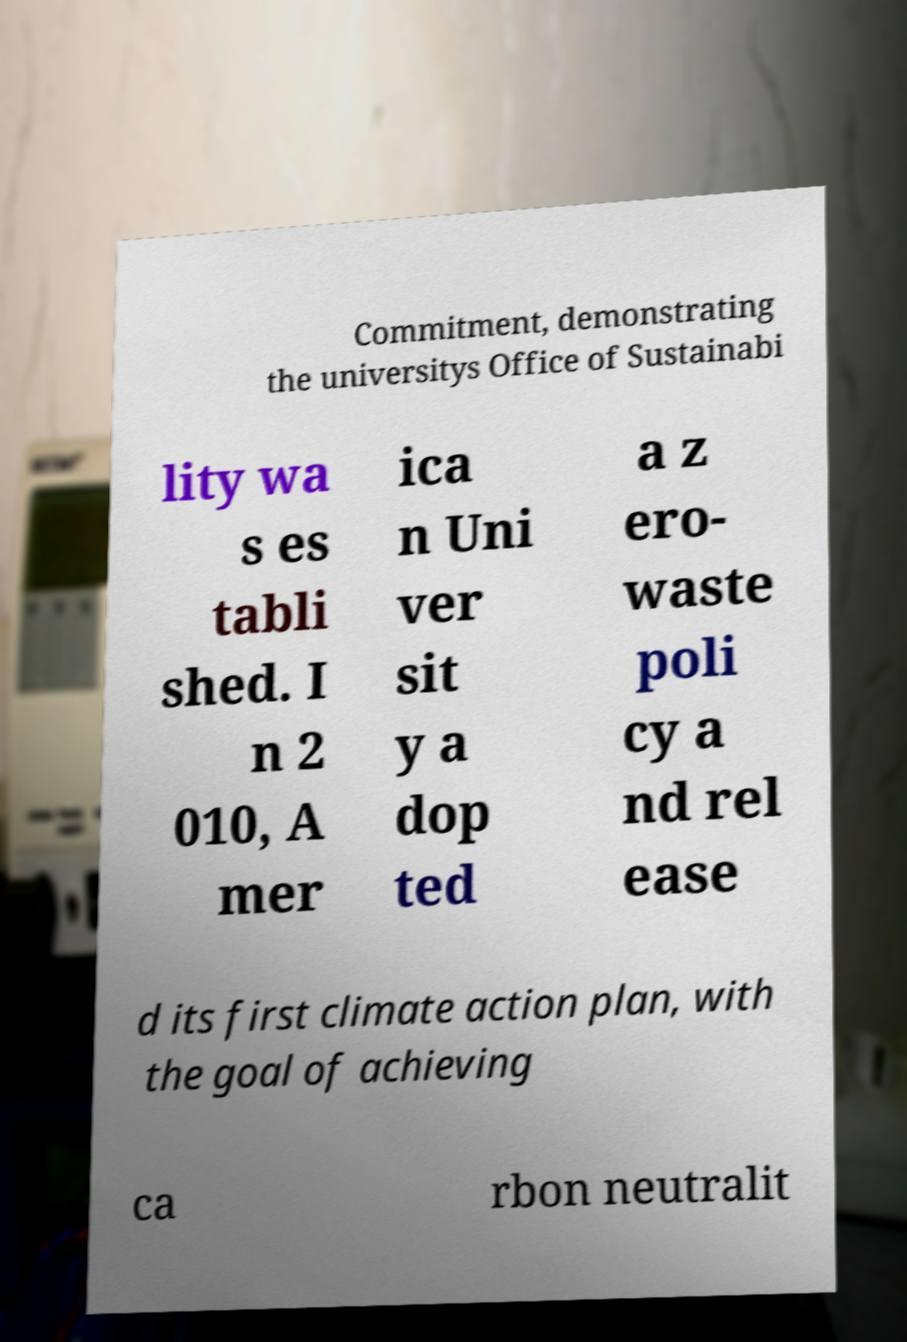For documentation purposes, I need the text within this image transcribed. Could you provide that? Commitment, demonstrating the universitys Office of Sustainabi lity wa s es tabli shed. I n 2 010, A mer ica n Uni ver sit y a dop ted a z ero- waste poli cy a nd rel ease d its first climate action plan, with the goal of achieving ca rbon neutralit 